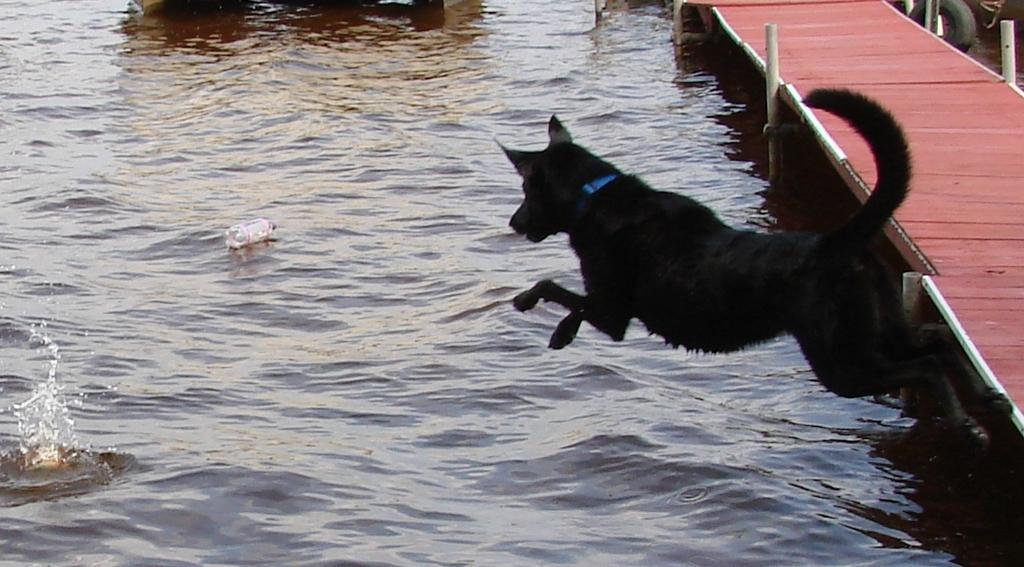What type of animal is in the image? There is a black dog in the image. What is the dog doing in the image? The dog is jumping. What can be seen on the right side of the image? There is a pier on the right side of the image. What is floating in the water in the image? There is a water bottle floating in the water. What type of wool is the dog wearing in the image? The dog is not wearing any wool in the image; it is a black dog that is jumping. How many fangs does the dog have in the image? The image does not show the dog's teeth or fangs, so it is not possible to determine the number of fangs. 